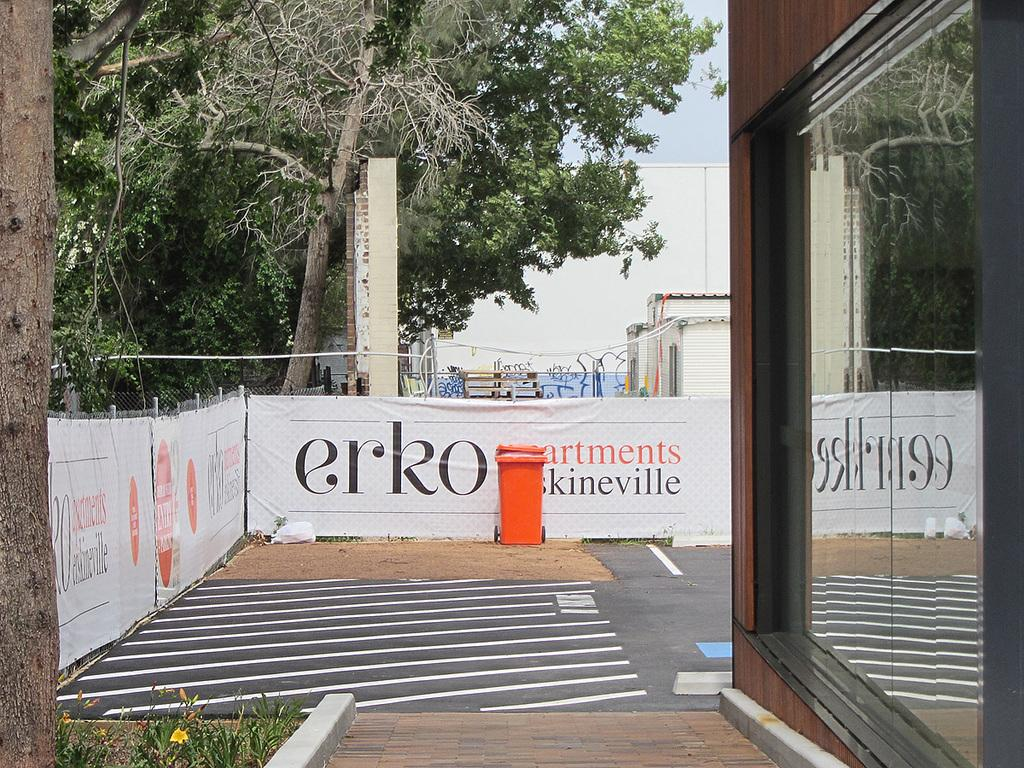What type of structure is present in the image? There is a building in the image. What surrounds the building? There is a fence around the building. What is attached to the fence? Banners are attached to the fence. What can be seen in the background of the image? Trees and the sky are visible in the background. What type of stew is being served at the event depicted in the image? There is no event or stew present in the image; it only shows a building with a fence and banners. What is the purpose of the rail in the image? There is no rail present in the image. 